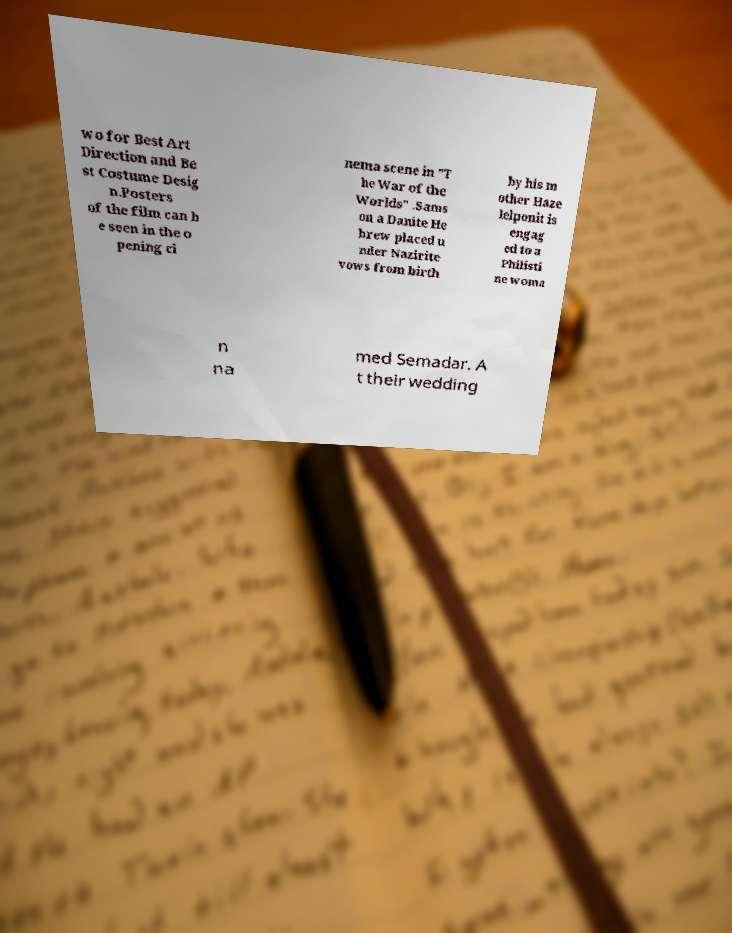Please identify and transcribe the text found in this image. wo for Best Art Direction and Be st Costume Desig n.Posters of the film can b e seen in the o pening ci nema scene in "T he War of the Worlds" .Sams on a Danite He brew placed u nder Nazirite vows from birth by his m other Haze lelponit is engag ed to a Philisti ne woma n na med Semadar. A t their wedding 